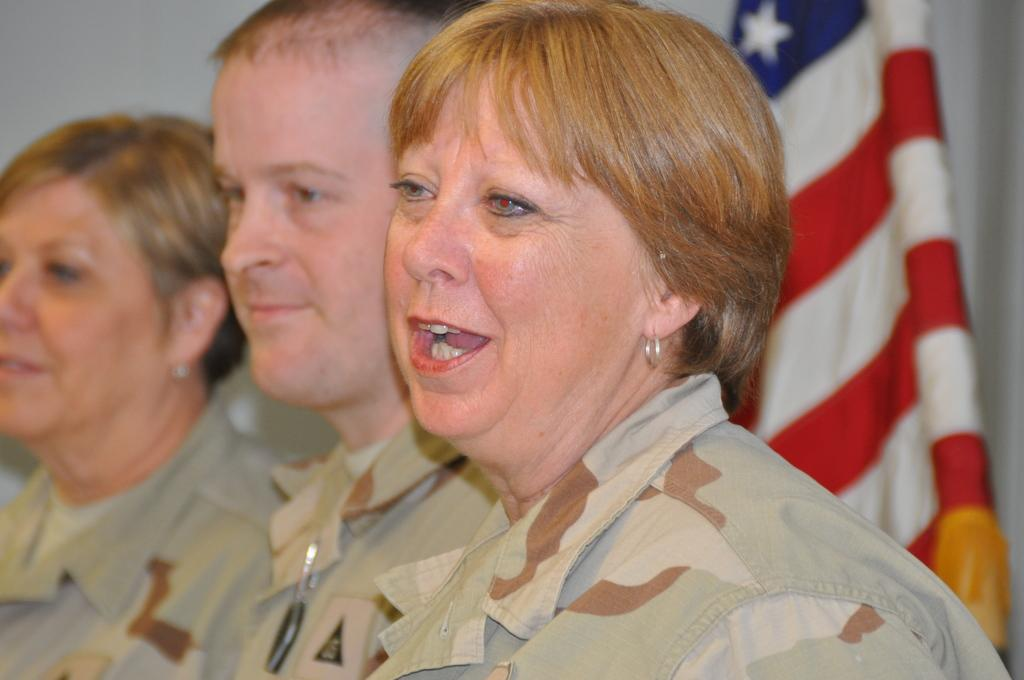How many people are in the image? There are three persons in the image. What are the persons doing in the image? The persons are standing and smiling. What can be seen in the image besides the people? There is a flag visible in the image. What type of door can be seen in the image? There is no door present in the image; it only features three persons standing and smiling, along with a visible flag. 